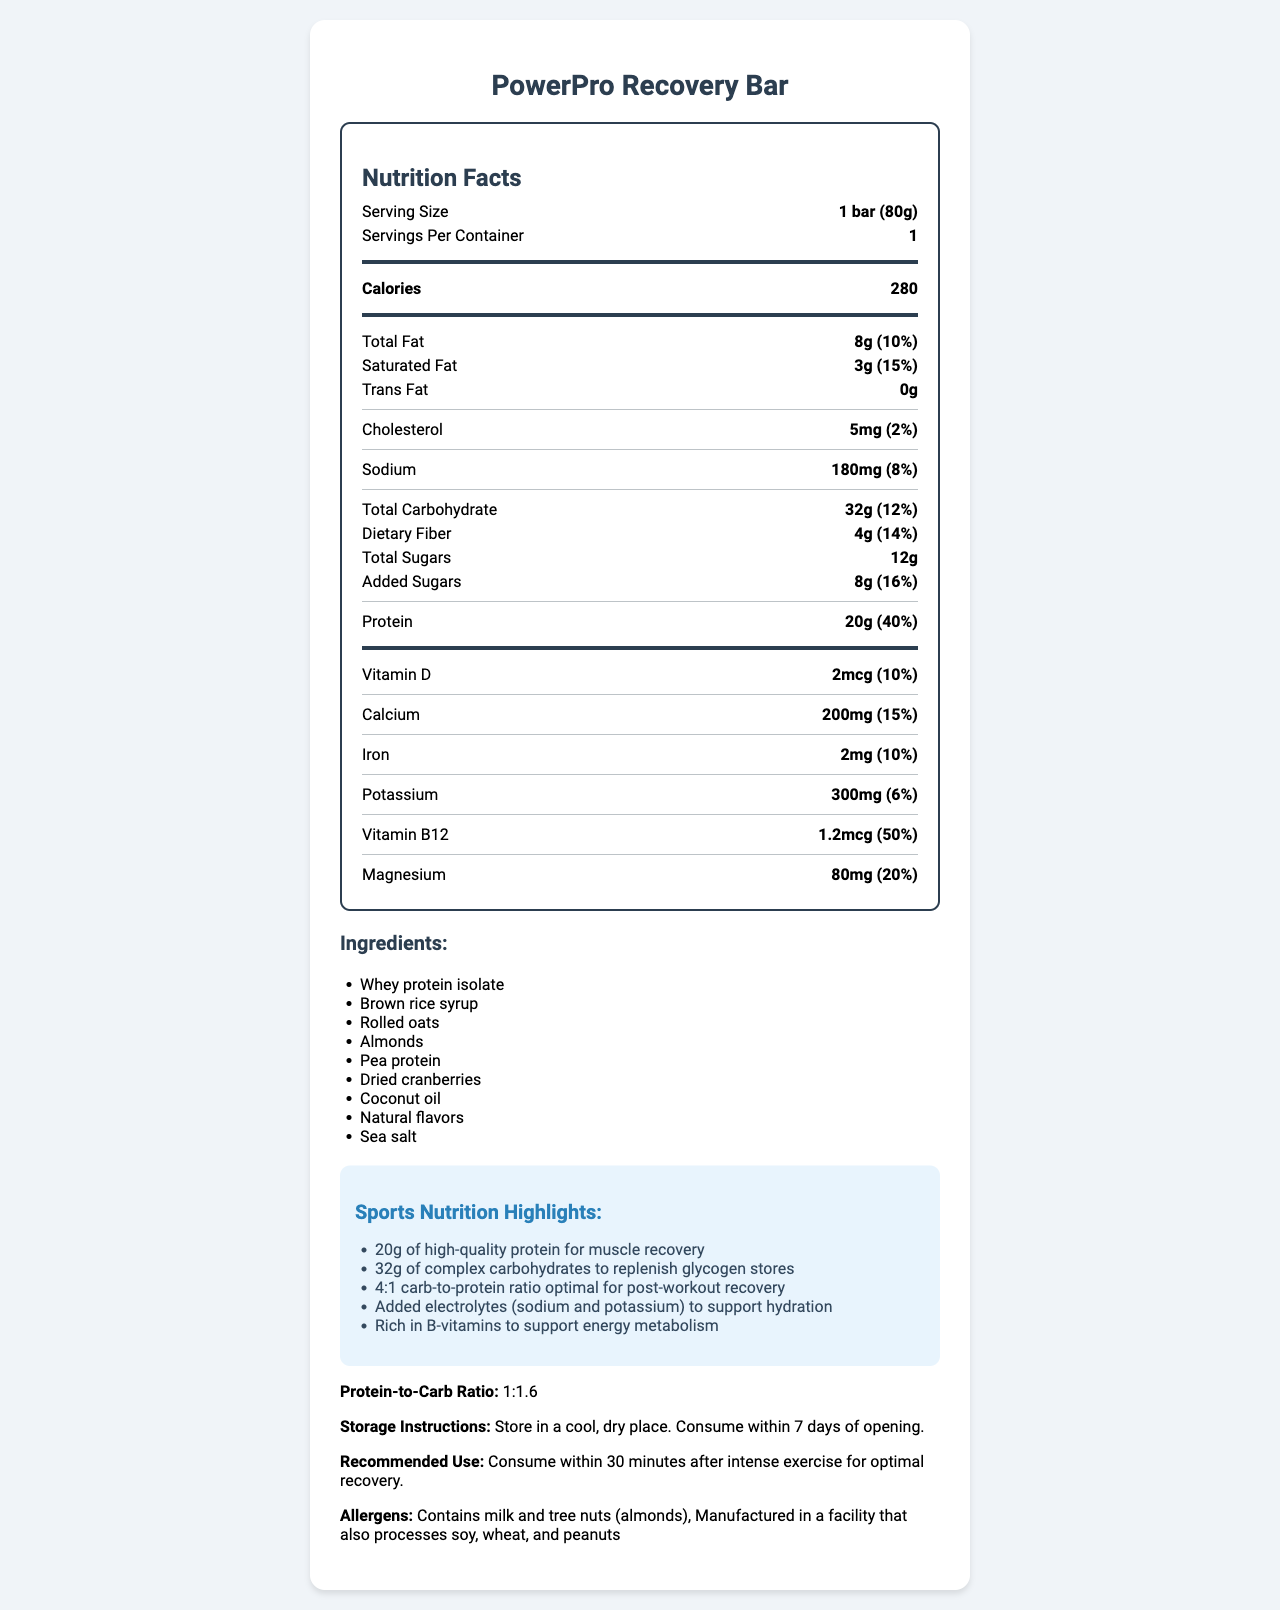what is the serving size of the PowerPro Recovery Bar? The serving size of the PowerPro Recovery Bar is clearly stated as "1 bar (80g)" in the document.
Answer: 1 bar (80g) how much protein does a PowerPro Recovery Bar contain? The document specifies that each bar contains 20g of protein.
Answer: 20g what is the protein-to-carb ratio of the PowerPro Recovery Bar? The document clearly indicates that the protein-to-carb ratio of the PowerPro Recovery Bar is 1:1.6.
Answer: 1:1.6 how many grams of total carbohydrate are there in one serving? The total carbohydrate content for one serving is listed as 32g in the document.
Answer: 32g what is the daily value percentage of protein in one PowerPro Recovery Bar? The document states that the daily value percentage of protein is 40%.
Answer: 40% which vitamin has the highest daily value percentage in the PowerPro Recovery Bar? A. Vitamin D B. Calcium C. Vitamin B12 D. Magnesium The document lists Vitamin B12 with a daily value percentage of 50%, which is the highest among the vitamins mentioned.
Answer: C. Vitamin B12 how much added sugar is in the PowerPro Recovery Bar? A. 8g B. 10g C. 12g D. 14g The document specifies that there are 8g of added sugars in the bar.
Answer: A. 8g does the PowerPro Recovery Bar contain any trans fat? The document states that the bar contains 0g of trans fat.
Answer: No is the PowerPro Recovery Bar suitable for someone with a peanut allergy? The document mentions that the bar is manufactured in a facility that also processes peanuts, making it potentially unsuitable for someone with a peanut allergy.
Answer: No summarize the main idea of the document. The document provides detailed nutritional information about the PowerPro Recovery Bar, focusing on its suitability for post-workout recovery and highlighting its protein-to-carb ratio, and various nutritional benefits.
Answer: The PowerPro Recovery Bar is a post-workout meal replacement bar designed to aid muscle recovery and replenish glycogen stores. It contains 20g of protein, 32g of carbohydrates, various vitamins and minerals, and is highlighted for its 1:1.6 protein-to-carb ratio. It also contains allergens such as milk and almonds and advises consumption within 30 minutes post-exercise. what is the exact amount of potassium in the PowerPro Recovery Bar? The document specifies the potassium content as 300mg.
Answer: 300mg which item is not among the ingredients of the PowerPro Recovery Bar? A. Whey protein isolate B. Brown rice syrup C. Pea protein D. Soy protein The document lists the ingredients, and soy protein is not among them.
Answer: D. Soy protein what is the recommended use for the PowerPro Recovery Bar? The document recommends consuming the bar within 30 minutes after intense exercise for optimal recovery.
Answer: Consume within 30 minutes after intense exercise for optimal recovery. how much cholesterol does the PowerPro Recovery Bar contain? The document states that each bar contains 5mg of cholesterol.
Answer: 5mg are there any storage instructions provided for the PowerPro Recovery Bar? The document states that the bar should be stored in a cool, dry place and consumed within 7 days of opening.
Answer: Yes how many calories does one PowerPro Recovery Bar provide? The document specifies that each bar provides 280 calories.
Answer: 280 what is the daily value percentage for dietary fiber in one serving of the PowerPro Recovery Bar? The document lists the daily value percentage for dietary fiber as 14%.
Answer: 14% how many servings are there per container of the PowerPro Recovery Bar? The document mentions that there is 1 serving per container.
Answer: 1 what is the source of protein in the PowerPro Recovery Bar? The document lists whey protein isolate and pea protein as sources of protein in the bar.
Answer: Whey protein isolate, Pea protein can you determine the exact manufacturing facility location from the document? The document does not provide the exact location of the manufacturing facility.
Answer: Cannot be determined 